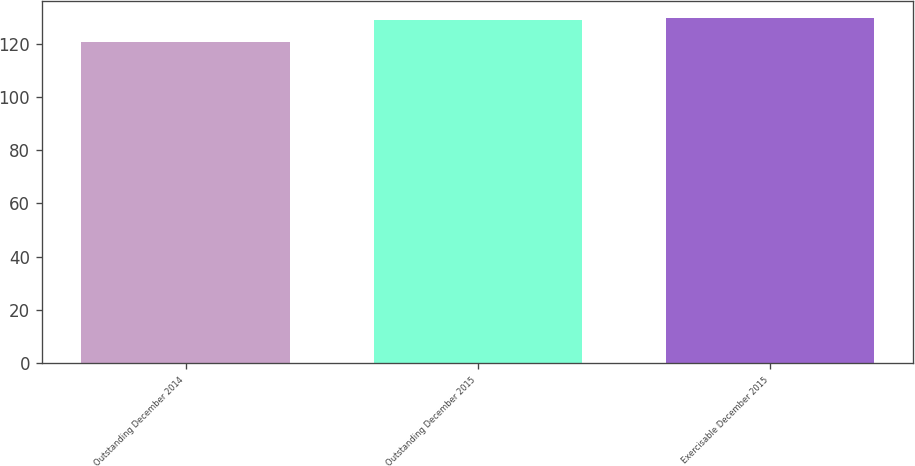Convert chart. <chart><loc_0><loc_0><loc_500><loc_500><bar_chart><fcel>Outstanding December 2014<fcel>Outstanding December 2015<fcel>Exercisable December 2015<nl><fcel>120.4<fcel>128.79<fcel>129.63<nl></chart> 